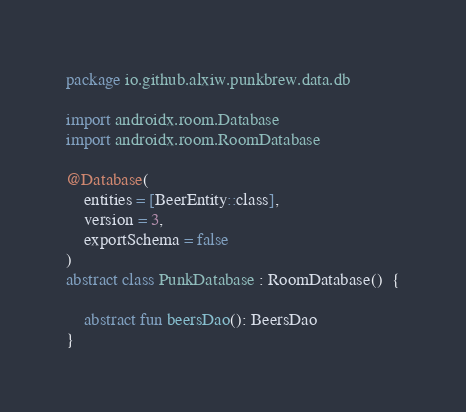<code> <loc_0><loc_0><loc_500><loc_500><_Kotlin_>package io.github.alxiw.punkbrew.data.db

import androidx.room.Database
import androidx.room.RoomDatabase

@Database(
    entities = [BeerEntity::class],
    version = 3,
    exportSchema = false
)
abstract class PunkDatabase : RoomDatabase()  {

    abstract fun beersDao(): BeersDao
}
</code> 